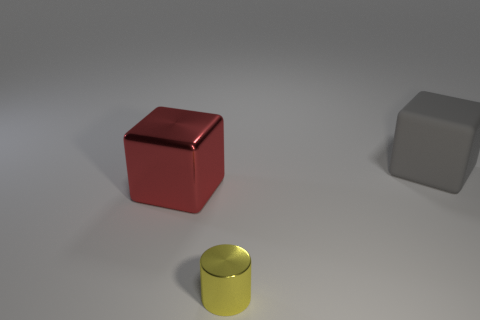There is a large object that is the same material as the small object; what color is it?
Offer a terse response. Red. How many tiny cylinders have the same material as the gray object?
Give a very brief answer. 0. What number of things are large gray blocks or big things on the right side of the tiny yellow object?
Your response must be concise. 1. Is the material of the big thing that is to the left of the tiny yellow cylinder the same as the yellow cylinder?
Your answer should be compact. Yes. What color is the cube that is the same size as the red thing?
Provide a succinct answer. Gray. Is there a matte object that has the same shape as the small metal object?
Provide a short and direct response. No. The cube to the left of the big object to the right of the block that is in front of the gray thing is what color?
Offer a terse response. Red. What number of metallic objects are gray cubes or tiny gray cylinders?
Ensure brevity in your answer.  0. Is the number of gray rubber objects on the left side of the rubber block greater than the number of cubes that are behind the red shiny thing?
Ensure brevity in your answer.  No. What number of other things are there of the same size as the metal cylinder?
Keep it short and to the point. 0. 